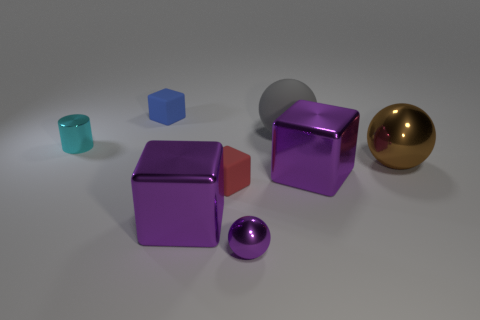Subtract all large balls. How many balls are left? 1 Add 2 red shiny cylinders. How many objects exist? 10 Subtract all red cylinders. How many purple cubes are left? 2 Subtract all cylinders. How many objects are left? 7 Subtract all blue cubes. How many cubes are left? 3 Subtract 1 gray spheres. How many objects are left? 7 Subtract all brown spheres. Subtract all purple blocks. How many spheres are left? 2 Subtract all small objects. Subtract all purple things. How many objects are left? 1 Add 6 brown things. How many brown things are left? 7 Add 5 small blue objects. How many small blue objects exist? 6 